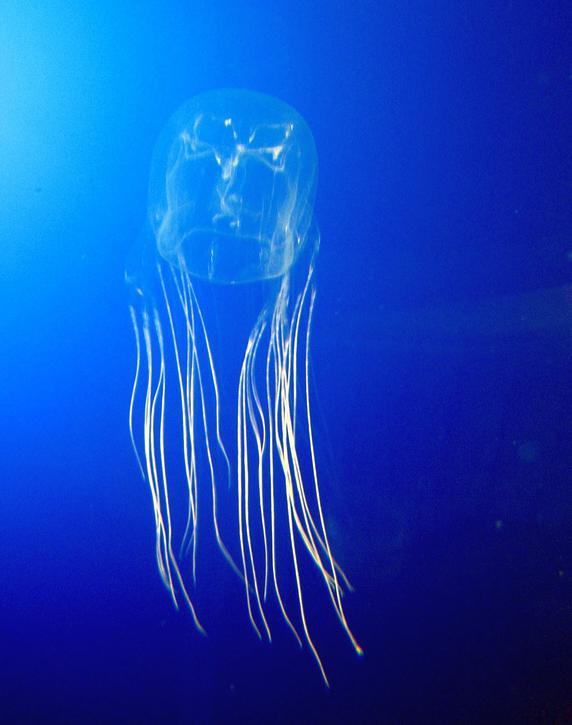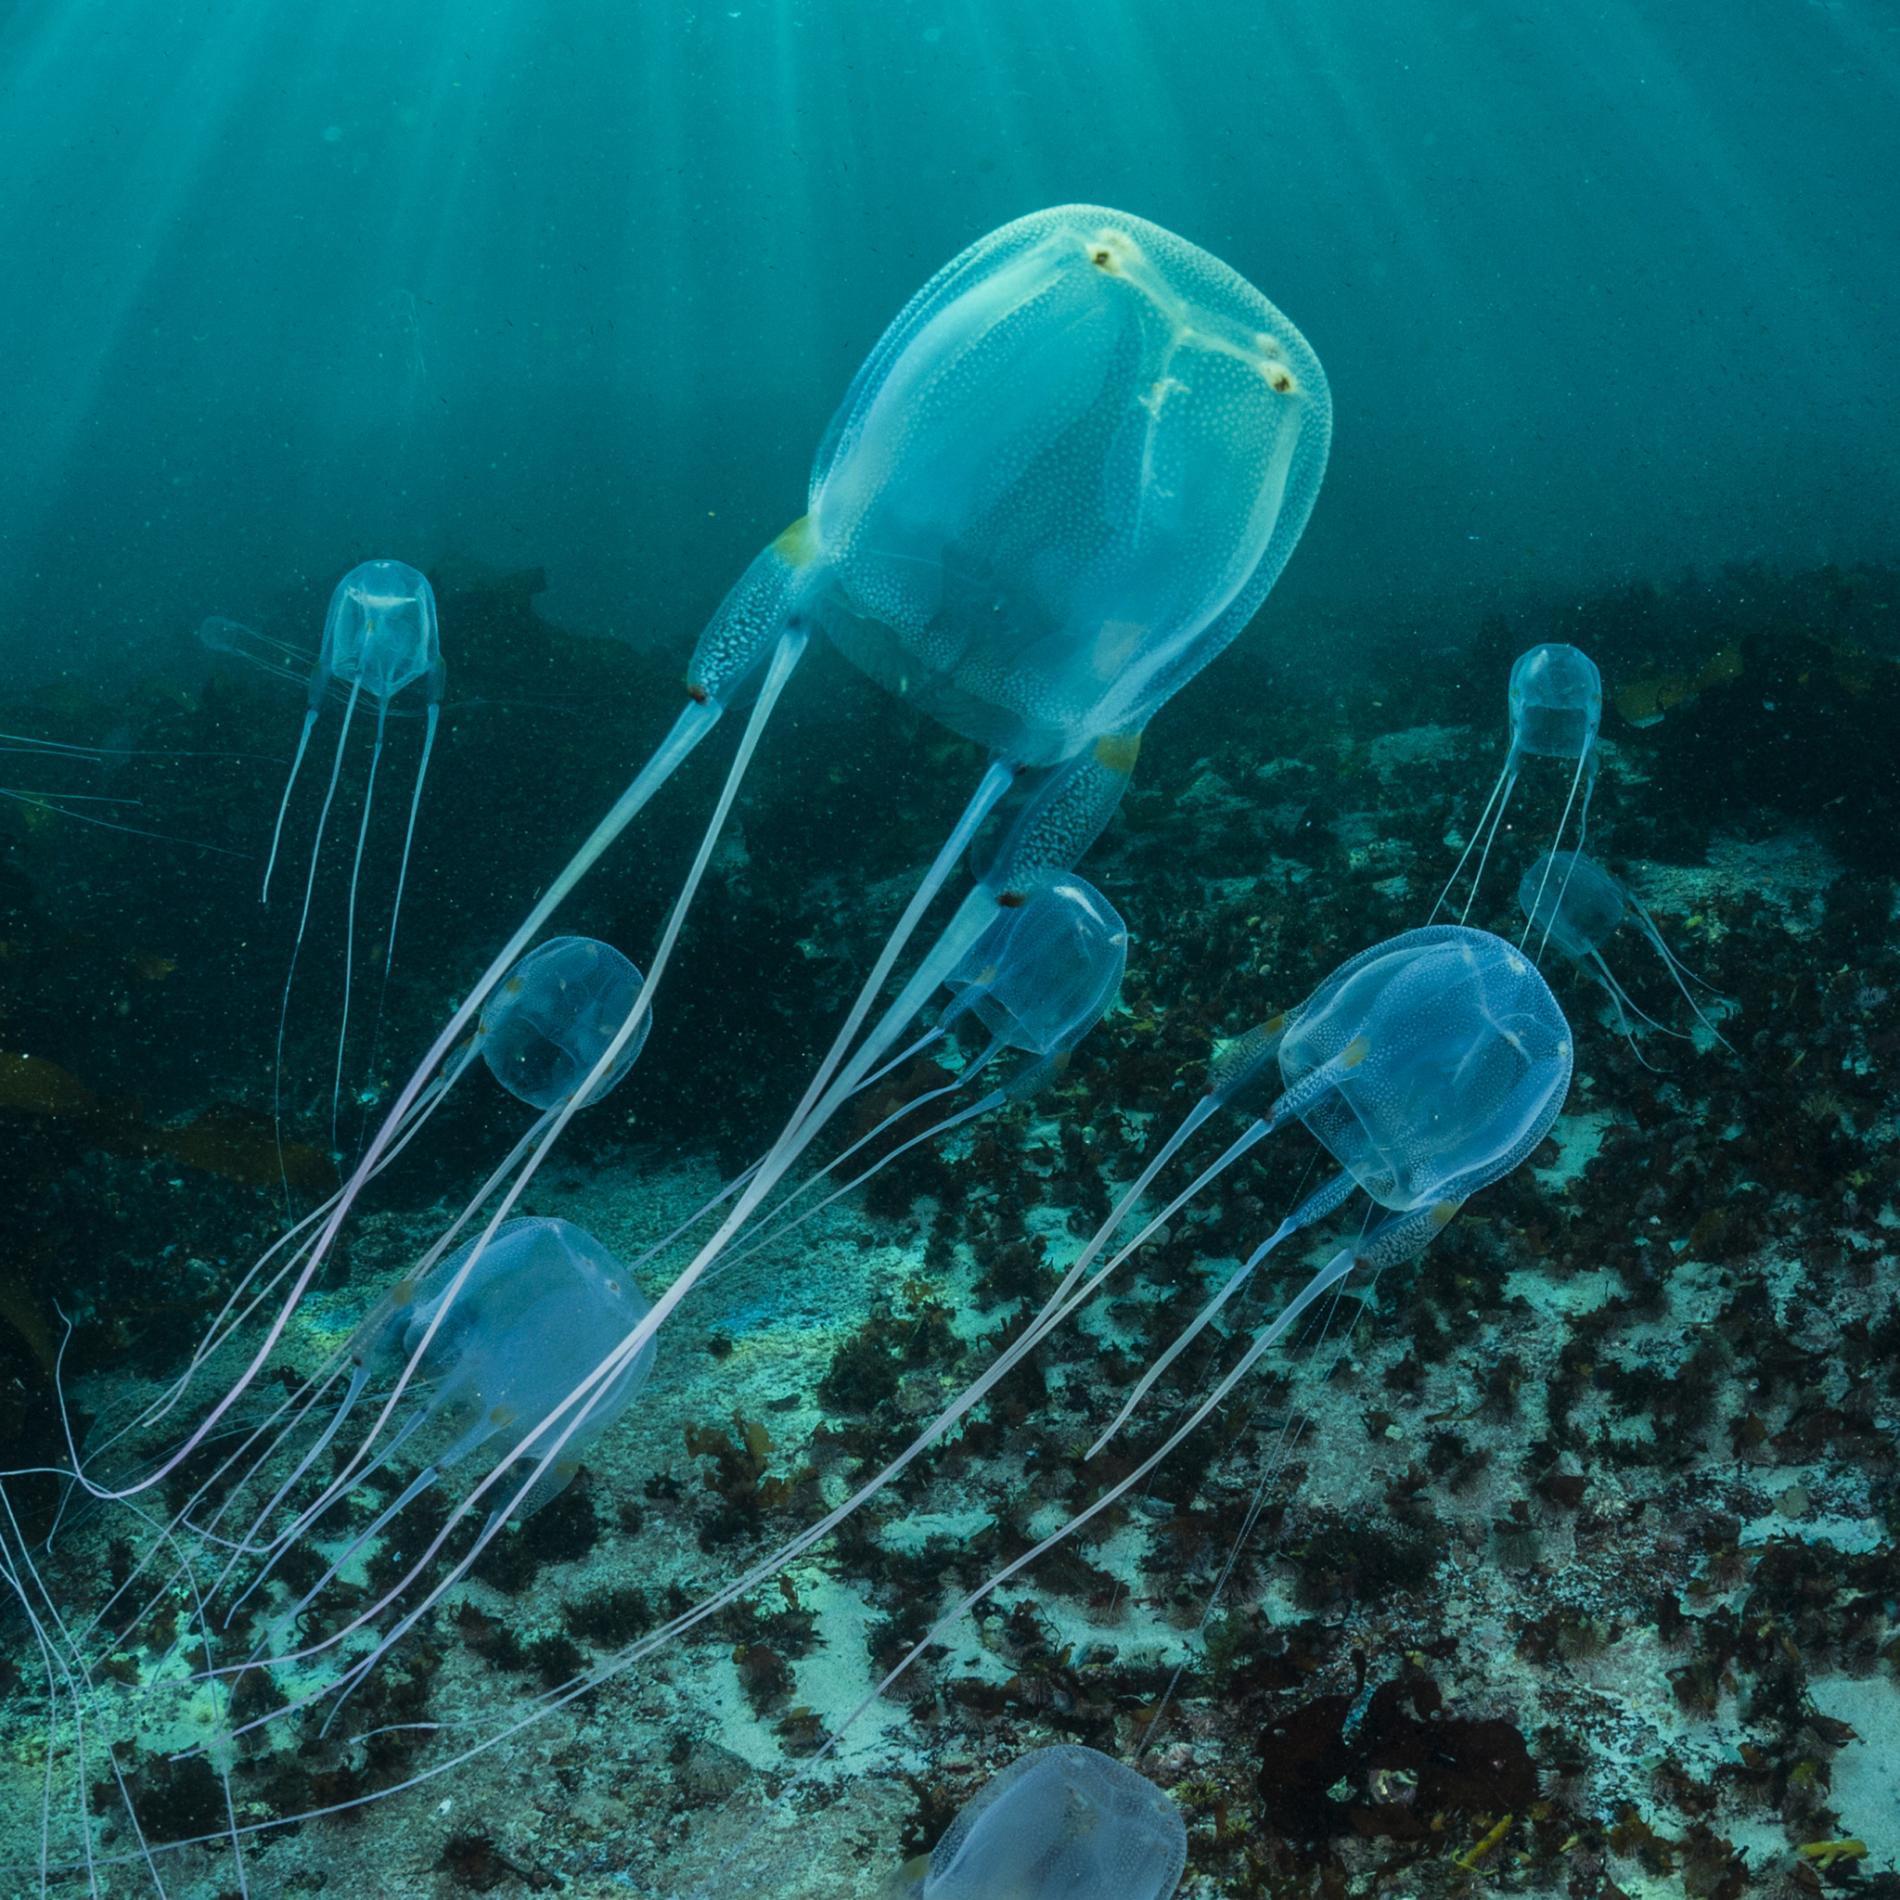The first image is the image on the left, the second image is the image on the right. Evaluate the accuracy of this statement regarding the images: "in the left image the jellyfish is swimming straight up". Is it true? Answer yes or no. Yes. The first image is the image on the left, the second image is the image on the right. Examine the images to the left and right. Is the description "Both images show a single jellyfish with a black background." accurate? Answer yes or no. No. 